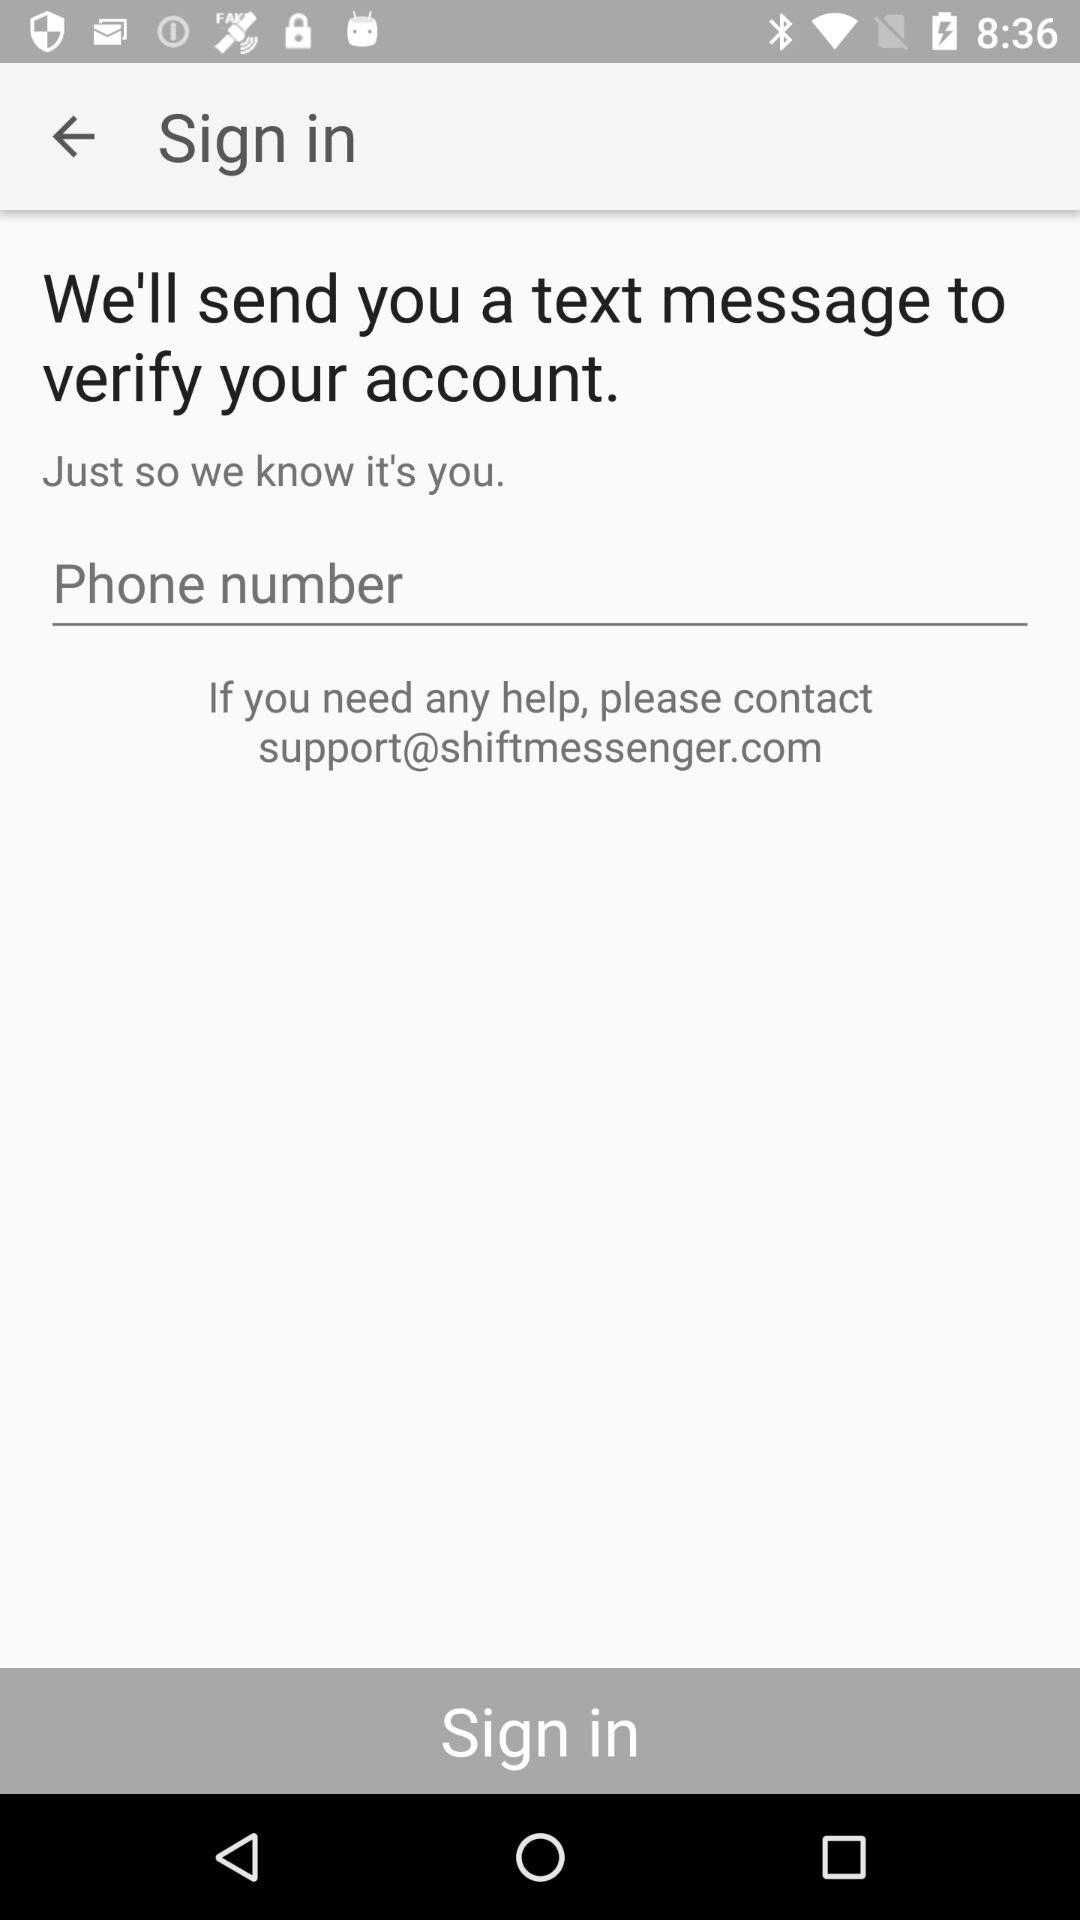What is the email address? The email address is support@shiftmessenger.com. 